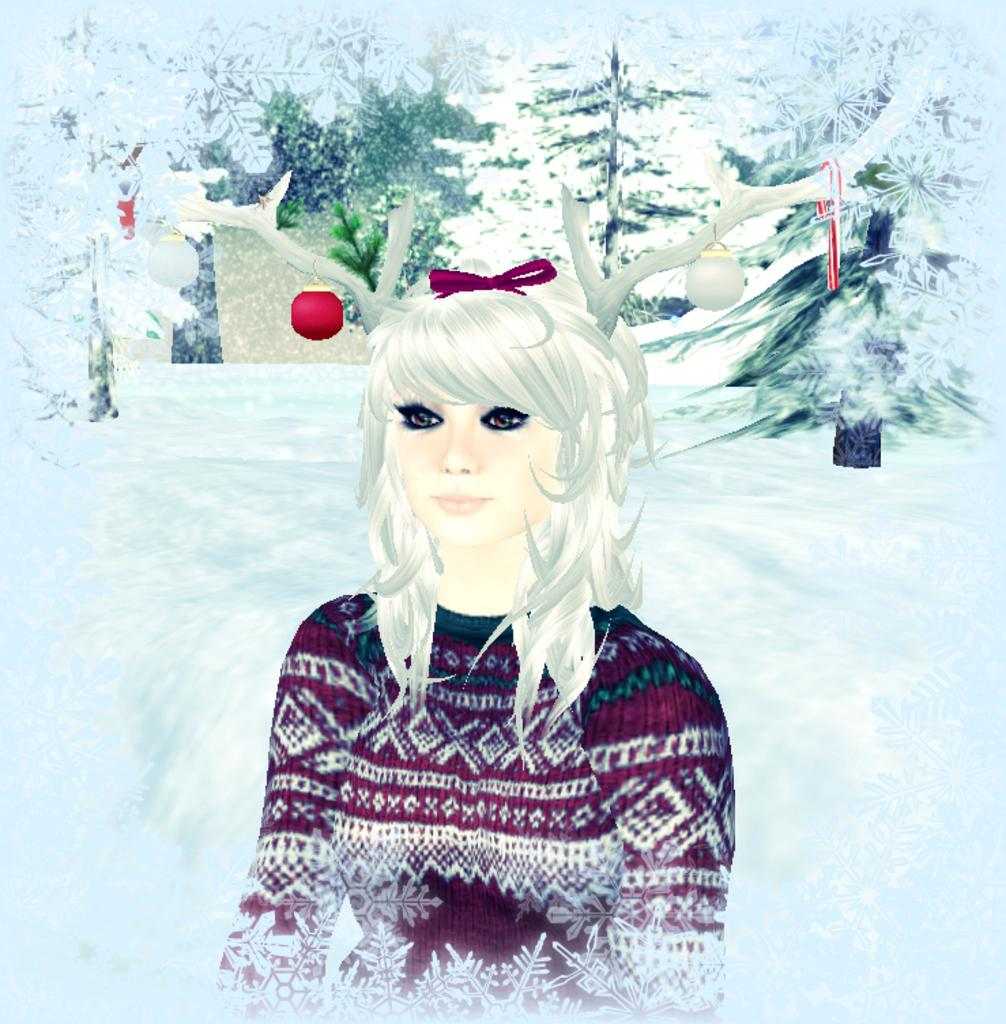What type of image is being described? A: The image is an animation and graphic. Can you describe the main subject in the image? There is a woman in the front of the image. What can be seen in the background of the image? There are trees in the background of the image. What is the weather condition in the image? There is snow visible in the image. What type of baseball equipment can be seen in the image? There is no baseball equipment present in the image. How many family members are visible in the image? There is no family depicted in the image; only a woman is present. 